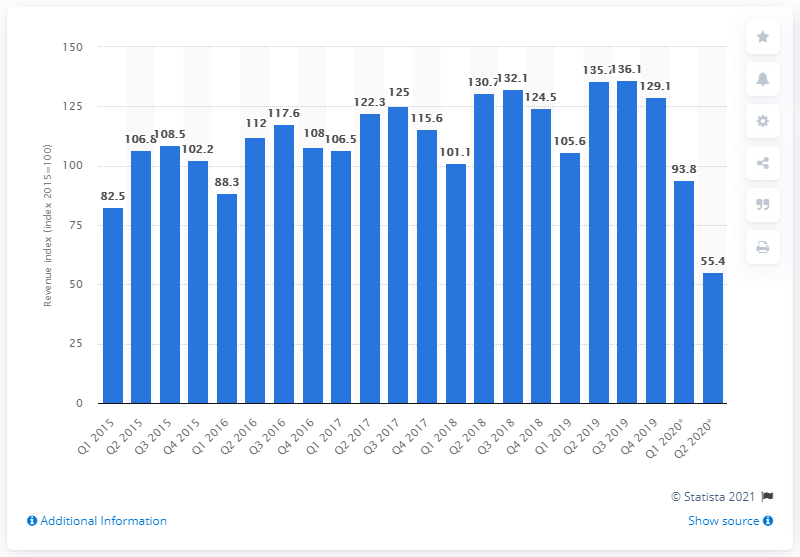Outline some significant characteristics in this image. According to the revenue index of the Dutch hospitality industry in the second quarter of 2019, the revenue was 55.4%. In the first quarter of 2019, the revenue index of the hospitality industry in the Netherlands was 105.6. 